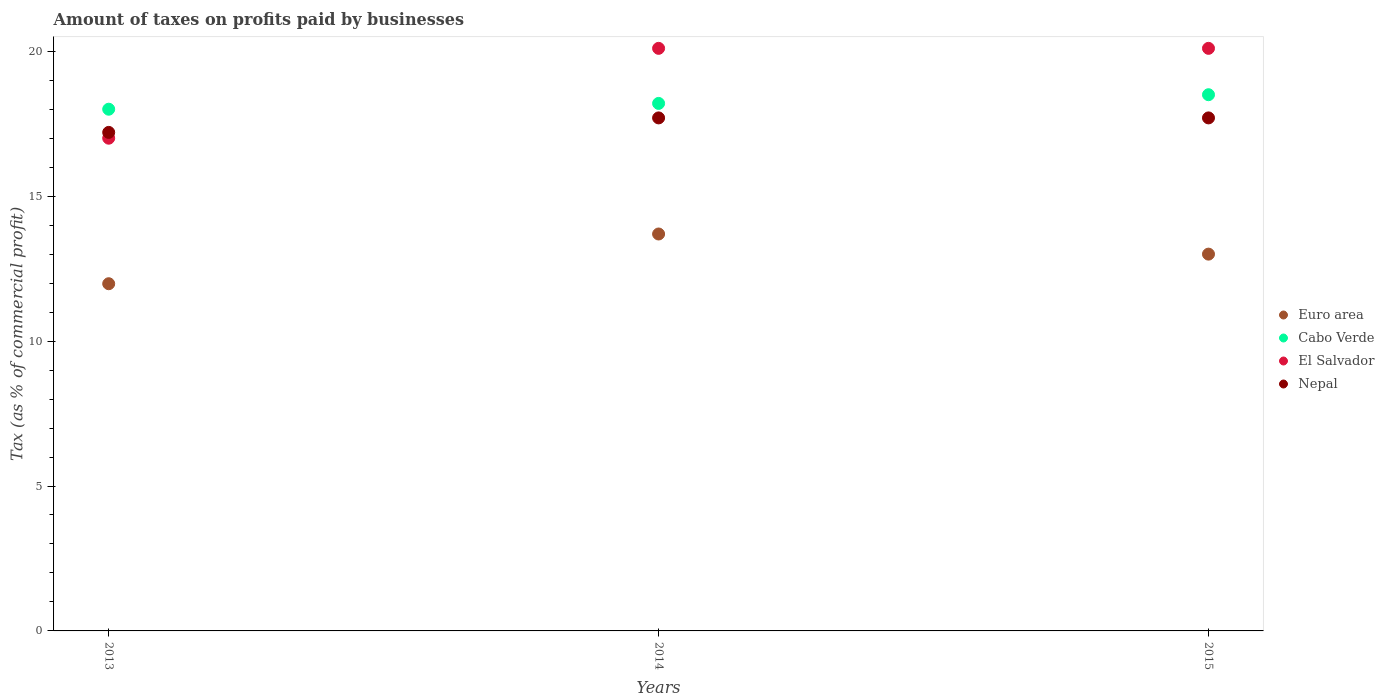Is the number of dotlines equal to the number of legend labels?
Your answer should be compact. Yes. What is the percentage of taxes paid by businesses in El Salvador in 2015?
Your answer should be very brief. 20.1. In which year was the percentage of taxes paid by businesses in El Salvador maximum?
Give a very brief answer. 2014. What is the total percentage of taxes paid by businesses in Cabo Verde in the graph?
Your answer should be very brief. 54.7. What is the difference between the percentage of taxes paid by businesses in El Salvador in 2013 and that in 2014?
Provide a short and direct response. -3.1. What is the difference between the percentage of taxes paid by businesses in El Salvador in 2015 and the percentage of taxes paid by businesses in Cabo Verde in 2014?
Offer a very short reply. 1.9. What is the average percentage of taxes paid by businesses in El Salvador per year?
Give a very brief answer. 19.07. In the year 2015, what is the difference between the percentage of taxes paid by businesses in El Salvador and percentage of taxes paid by businesses in Euro area?
Offer a terse response. 7.1. In how many years, is the percentage of taxes paid by businesses in Nepal greater than 12 %?
Make the answer very short. 3. What is the ratio of the percentage of taxes paid by businesses in El Salvador in 2013 to that in 2014?
Make the answer very short. 0.85. Is the difference between the percentage of taxes paid by businesses in El Salvador in 2014 and 2015 greater than the difference between the percentage of taxes paid by businesses in Euro area in 2014 and 2015?
Make the answer very short. No. What is the difference between the highest and the second highest percentage of taxes paid by businesses in El Salvador?
Your answer should be very brief. 0. What is the difference between the highest and the lowest percentage of taxes paid by businesses in El Salvador?
Your answer should be compact. 3.1. Is the sum of the percentage of taxes paid by businesses in El Salvador in 2013 and 2015 greater than the maximum percentage of taxes paid by businesses in Nepal across all years?
Make the answer very short. Yes. Is it the case that in every year, the sum of the percentage of taxes paid by businesses in Cabo Verde and percentage of taxes paid by businesses in El Salvador  is greater than the sum of percentage of taxes paid by businesses in Nepal and percentage of taxes paid by businesses in Euro area?
Offer a terse response. Yes. Does the percentage of taxes paid by businesses in Cabo Verde monotonically increase over the years?
Your answer should be very brief. Yes. Is the percentage of taxes paid by businesses in El Salvador strictly greater than the percentage of taxes paid by businesses in Euro area over the years?
Your answer should be very brief. Yes. How many dotlines are there?
Give a very brief answer. 4. Are the values on the major ticks of Y-axis written in scientific E-notation?
Your answer should be compact. No. Does the graph contain any zero values?
Provide a succinct answer. No. How many legend labels are there?
Your response must be concise. 4. How are the legend labels stacked?
Offer a terse response. Vertical. What is the title of the graph?
Make the answer very short. Amount of taxes on profits paid by businesses. What is the label or title of the X-axis?
Keep it short and to the point. Years. What is the label or title of the Y-axis?
Keep it short and to the point. Tax (as % of commercial profit). What is the Tax (as % of commercial profit) in Euro area in 2013?
Your answer should be very brief. 11.98. What is the Tax (as % of commercial profit) of Cabo Verde in 2013?
Make the answer very short. 18. What is the Tax (as % of commercial profit) of El Salvador in 2013?
Your answer should be very brief. 17. What is the Tax (as % of commercial profit) in Euro area in 2014?
Give a very brief answer. 13.69. What is the Tax (as % of commercial profit) in El Salvador in 2014?
Your answer should be compact. 20.1. What is the Tax (as % of commercial profit) in El Salvador in 2015?
Ensure brevity in your answer.  20.1. Across all years, what is the maximum Tax (as % of commercial profit) in Euro area?
Your answer should be very brief. 13.69. Across all years, what is the maximum Tax (as % of commercial profit) in El Salvador?
Your answer should be very brief. 20.1. Across all years, what is the maximum Tax (as % of commercial profit) in Nepal?
Give a very brief answer. 17.7. Across all years, what is the minimum Tax (as % of commercial profit) of Euro area?
Your answer should be very brief. 11.98. Across all years, what is the minimum Tax (as % of commercial profit) in El Salvador?
Provide a short and direct response. 17. What is the total Tax (as % of commercial profit) of Euro area in the graph?
Offer a very short reply. 38.67. What is the total Tax (as % of commercial profit) of Cabo Verde in the graph?
Your answer should be compact. 54.7. What is the total Tax (as % of commercial profit) of El Salvador in the graph?
Your response must be concise. 57.2. What is the total Tax (as % of commercial profit) in Nepal in the graph?
Offer a terse response. 52.6. What is the difference between the Tax (as % of commercial profit) in Euro area in 2013 and that in 2014?
Provide a short and direct response. -1.72. What is the difference between the Tax (as % of commercial profit) in Cabo Verde in 2013 and that in 2014?
Keep it short and to the point. -0.2. What is the difference between the Tax (as % of commercial profit) of El Salvador in 2013 and that in 2014?
Keep it short and to the point. -3.1. What is the difference between the Tax (as % of commercial profit) of Nepal in 2013 and that in 2014?
Give a very brief answer. -0.5. What is the difference between the Tax (as % of commercial profit) in Euro area in 2013 and that in 2015?
Make the answer very short. -1.02. What is the difference between the Tax (as % of commercial profit) in Euro area in 2014 and that in 2015?
Your response must be concise. 0.69. What is the difference between the Tax (as % of commercial profit) in El Salvador in 2014 and that in 2015?
Offer a terse response. 0. What is the difference between the Tax (as % of commercial profit) in Euro area in 2013 and the Tax (as % of commercial profit) in Cabo Verde in 2014?
Offer a terse response. -6.22. What is the difference between the Tax (as % of commercial profit) of Euro area in 2013 and the Tax (as % of commercial profit) of El Salvador in 2014?
Your answer should be very brief. -8.12. What is the difference between the Tax (as % of commercial profit) of Euro area in 2013 and the Tax (as % of commercial profit) of Nepal in 2014?
Provide a succinct answer. -5.72. What is the difference between the Tax (as % of commercial profit) of Cabo Verde in 2013 and the Tax (as % of commercial profit) of El Salvador in 2014?
Offer a terse response. -2.1. What is the difference between the Tax (as % of commercial profit) of Cabo Verde in 2013 and the Tax (as % of commercial profit) of Nepal in 2014?
Your answer should be compact. 0.3. What is the difference between the Tax (as % of commercial profit) in El Salvador in 2013 and the Tax (as % of commercial profit) in Nepal in 2014?
Offer a terse response. -0.7. What is the difference between the Tax (as % of commercial profit) in Euro area in 2013 and the Tax (as % of commercial profit) in Cabo Verde in 2015?
Ensure brevity in your answer.  -6.52. What is the difference between the Tax (as % of commercial profit) in Euro area in 2013 and the Tax (as % of commercial profit) in El Salvador in 2015?
Offer a terse response. -8.12. What is the difference between the Tax (as % of commercial profit) in Euro area in 2013 and the Tax (as % of commercial profit) in Nepal in 2015?
Your answer should be very brief. -5.72. What is the difference between the Tax (as % of commercial profit) of Cabo Verde in 2013 and the Tax (as % of commercial profit) of Nepal in 2015?
Offer a terse response. 0.3. What is the difference between the Tax (as % of commercial profit) in El Salvador in 2013 and the Tax (as % of commercial profit) in Nepal in 2015?
Make the answer very short. -0.7. What is the difference between the Tax (as % of commercial profit) of Euro area in 2014 and the Tax (as % of commercial profit) of Cabo Verde in 2015?
Provide a succinct answer. -4.81. What is the difference between the Tax (as % of commercial profit) in Euro area in 2014 and the Tax (as % of commercial profit) in El Salvador in 2015?
Ensure brevity in your answer.  -6.41. What is the difference between the Tax (as % of commercial profit) of Euro area in 2014 and the Tax (as % of commercial profit) of Nepal in 2015?
Your answer should be compact. -4.01. What is the average Tax (as % of commercial profit) of Euro area per year?
Ensure brevity in your answer.  12.89. What is the average Tax (as % of commercial profit) of Cabo Verde per year?
Your answer should be compact. 18.23. What is the average Tax (as % of commercial profit) in El Salvador per year?
Give a very brief answer. 19.07. What is the average Tax (as % of commercial profit) in Nepal per year?
Ensure brevity in your answer.  17.53. In the year 2013, what is the difference between the Tax (as % of commercial profit) of Euro area and Tax (as % of commercial profit) of Cabo Verde?
Give a very brief answer. -6.02. In the year 2013, what is the difference between the Tax (as % of commercial profit) of Euro area and Tax (as % of commercial profit) of El Salvador?
Provide a succinct answer. -5.02. In the year 2013, what is the difference between the Tax (as % of commercial profit) in Euro area and Tax (as % of commercial profit) in Nepal?
Ensure brevity in your answer.  -5.22. In the year 2013, what is the difference between the Tax (as % of commercial profit) in Cabo Verde and Tax (as % of commercial profit) in El Salvador?
Give a very brief answer. 1. In the year 2013, what is the difference between the Tax (as % of commercial profit) in Cabo Verde and Tax (as % of commercial profit) in Nepal?
Ensure brevity in your answer.  0.8. In the year 2014, what is the difference between the Tax (as % of commercial profit) in Euro area and Tax (as % of commercial profit) in Cabo Verde?
Your answer should be very brief. -4.51. In the year 2014, what is the difference between the Tax (as % of commercial profit) in Euro area and Tax (as % of commercial profit) in El Salvador?
Your answer should be compact. -6.41. In the year 2014, what is the difference between the Tax (as % of commercial profit) in Euro area and Tax (as % of commercial profit) in Nepal?
Provide a short and direct response. -4.01. In the year 2014, what is the difference between the Tax (as % of commercial profit) of Cabo Verde and Tax (as % of commercial profit) of El Salvador?
Offer a terse response. -1.9. In the year 2014, what is the difference between the Tax (as % of commercial profit) in El Salvador and Tax (as % of commercial profit) in Nepal?
Give a very brief answer. 2.4. In the year 2015, what is the difference between the Tax (as % of commercial profit) of Euro area and Tax (as % of commercial profit) of El Salvador?
Your answer should be very brief. -7.1. In the year 2015, what is the difference between the Tax (as % of commercial profit) of Cabo Verde and Tax (as % of commercial profit) of El Salvador?
Ensure brevity in your answer.  -1.6. In the year 2015, what is the difference between the Tax (as % of commercial profit) in Cabo Verde and Tax (as % of commercial profit) in Nepal?
Provide a succinct answer. 0.8. What is the ratio of the Tax (as % of commercial profit) in Euro area in 2013 to that in 2014?
Make the answer very short. 0.87. What is the ratio of the Tax (as % of commercial profit) of Cabo Verde in 2013 to that in 2014?
Keep it short and to the point. 0.99. What is the ratio of the Tax (as % of commercial profit) of El Salvador in 2013 to that in 2014?
Your response must be concise. 0.85. What is the ratio of the Tax (as % of commercial profit) of Nepal in 2013 to that in 2014?
Give a very brief answer. 0.97. What is the ratio of the Tax (as % of commercial profit) in Euro area in 2013 to that in 2015?
Your response must be concise. 0.92. What is the ratio of the Tax (as % of commercial profit) of Cabo Verde in 2013 to that in 2015?
Offer a very short reply. 0.97. What is the ratio of the Tax (as % of commercial profit) of El Salvador in 2013 to that in 2015?
Your response must be concise. 0.85. What is the ratio of the Tax (as % of commercial profit) of Nepal in 2013 to that in 2015?
Provide a succinct answer. 0.97. What is the ratio of the Tax (as % of commercial profit) in Euro area in 2014 to that in 2015?
Provide a succinct answer. 1.05. What is the ratio of the Tax (as % of commercial profit) in Cabo Verde in 2014 to that in 2015?
Make the answer very short. 0.98. What is the ratio of the Tax (as % of commercial profit) of El Salvador in 2014 to that in 2015?
Offer a very short reply. 1. What is the difference between the highest and the second highest Tax (as % of commercial profit) in Euro area?
Your answer should be very brief. 0.69. What is the difference between the highest and the second highest Tax (as % of commercial profit) in El Salvador?
Provide a succinct answer. 0. What is the difference between the highest and the second highest Tax (as % of commercial profit) in Nepal?
Your answer should be compact. 0. What is the difference between the highest and the lowest Tax (as % of commercial profit) of Euro area?
Your answer should be compact. 1.72. 